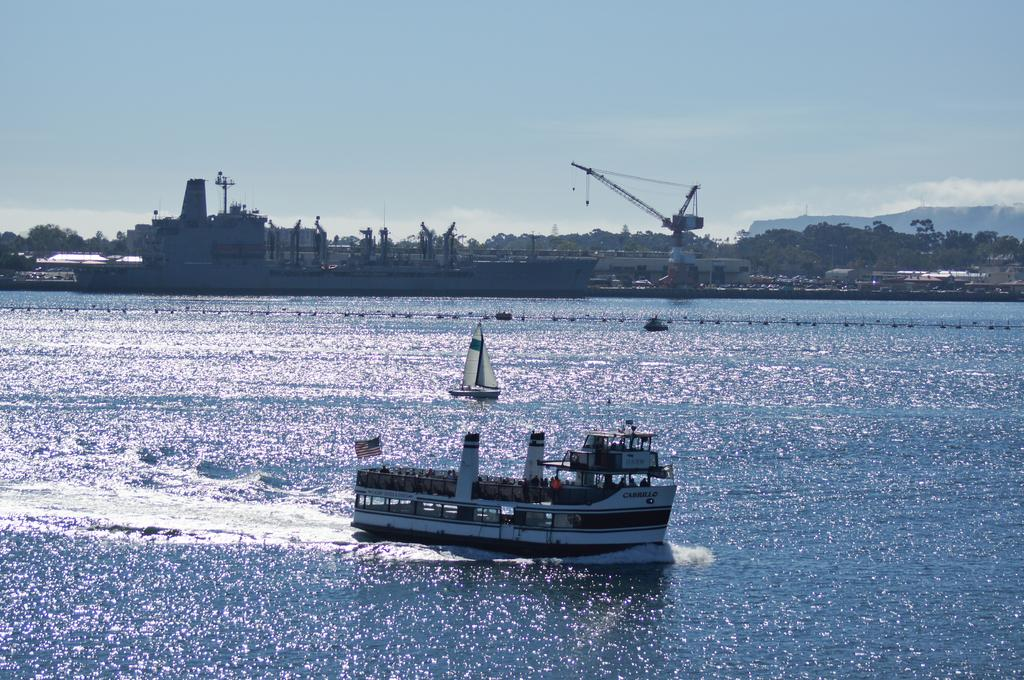What is the main subject of the image? The main subject of the image is a ship. What is the ship doing in the image? The ship is sailing on a sea. What can be seen in the background of the image? There is a harbour crane and trees in the background of the image. What type of crib can be seen in the image? There is no crib present in the image. What type of underwear is the ship wearing in the image? Ships do not wear underwear, as they are inanimate objects. How many cups are visible in the image? There is no cup present in the image. 